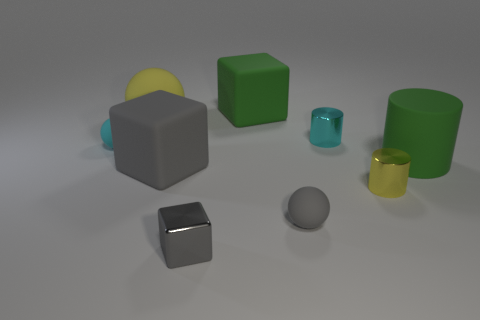Is the number of big gray objects that are in front of the yellow matte object greater than the number of big gray things that are to the left of the small gray rubber ball?
Make the answer very short. No. How many other things are there of the same size as the yellow ball?
Make the answer very short. 3. There is a gray metal object; is its shape the same as the shiny thing that is right of the small cyan metal cylinder?
Your answer should be very brief. No. What number of shiny things are either large cubes or big spheres?
Provide a short and direct response. 0. Is there a small rubber ball of the same color as the rubber cylinder?
Your answer should be compact. No. Are there any large spheres?
Give a very brief answer. Yes. Does the small cyan metallic thing have the same shape as the yellow rubber object?
Keep it short and to the point. No. How many large things are cyan matte balls or gray matte balls?
Ensure brevity in your answer.  0. The tiny cube is what color?
Keep it short and to the point. Gray. There is a small cyan thing that is to the left of the cyan object that is right of the large ball; what shape is it?
Ensure brevity in your answer.  Sphere. 